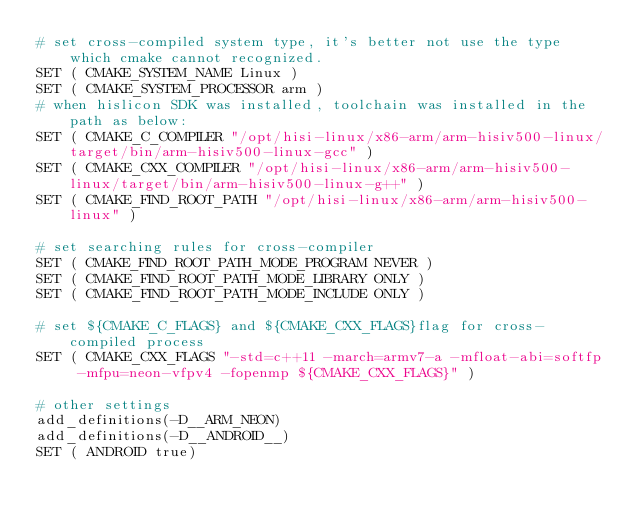Convert code to text. <code><loc_0><loc_0><loc_500><loc_500><_CMake_># set cross-compiled system type, it's better not use the type which cmake cannot recognized.
SET ( CMAKE_SYSTEM_NAME Linux )
SET ( CMAKE_SYSTEM_PROCESSOR arm )
# when hislicon SDK was installed, toolchain was installed in the path as below: 
SET ( CMAKE_C_COMPILER "/opt/hisi-linux/x86-arm/arm-hisiv500-linux/target/bin/arm-hisiv500-linux-gcc" )
SET ( CMAKE_CXX_COMPILER "/opt/hisi-linux/x86-arm/arm-hisiv500-linux/target/bin/arm-hisiv500-linux-g++" )
SET ( CMAKE_FIND_ROOT_PATH "/opt/hisi-linux/x86-arm/arm-hisiv500-linux" )

# set searching rules for cross-compiler
SET ( CMAKE_FIND_ROOT_PATH_MODE_PROGRAM NEVER )
SET ( CMAKE_FIND_ROOT_PATH_MODE_LIBRARY ONLY )
SET ( CMAKE_FIND_ROOT_PATH_MODE_INCLUDE ONLY )

# set ${CMAKE_C_FLAGS} and ${CMAKE_CXX_FLAGS}flag for cross-compiled process
SET ( CMAKE_CXX_FLAGS "-std=c++11 -march=armv7-a -mfloat-abi=softfp -mfpu=neon-vfpv4 -fopenmp ${CMAKE_CXX_FLAGS}" )

# other settings
add_definitions(-D__ARM_NEON)
add_definitions(-D__ANDROID__)
SET ( ANDROID true)
</code> 